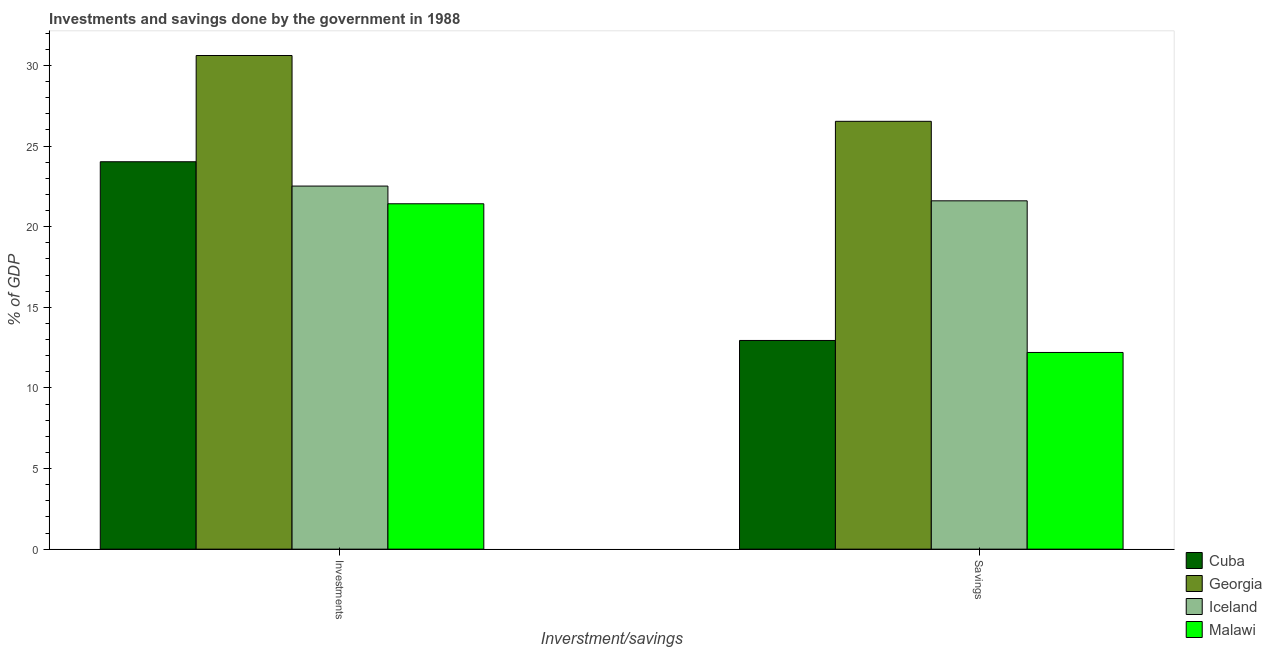How many groups of bars are there?
Ensure brevity in your answer.  2. Are the number of bars on each tick of the X-axis equal?
Keep it short and to the point. Yes. How many bars are there on the 2nd tick from the left?
Make the answer very short. 4. What is the label of the 2nd group of bars from the left?
Offer a very short reply. Savings. What is the savings of government in Georgia?
Ensure brevity in your answer.  26.53. Across all countries, what is the maximum savings of government?
Your response must be concise. 26.53. Across all countries, what is the minimum savings of government?
Your answer should be compact. 12.2. In which country was the savings of government maximum?
Ensure brevity in your answer.  Georgia. In which country was the investments of government minimum?
Provide a succinct answer. Malawi. What is the total savings of government in the graph?
Provide a short and direct response. 73.27. What is the difference between the investments of government in Georgia and that in Cuba?
Make the answer very short. 6.59. What is the difference between the savings of government in Cuba and the investments of government in Iceland?
Make the answer very short. -9.57. What is the average savings of government per country?
Keep it short and to the point. 18.32. What is the difference between the investments of government and savings of government in Malawi?
Ensure brevity in your answer.  9.22. In how many countries, is the savings of government greater than 29 %?
Your response must be concise. 0. What is the ratio of the investments of government in Malawi to that in Georgia?
Give a very brief answer. 0.7. What does the 2nd bar from the left in Savings represents?
Keep it short and to the point. Georgia. What does the 3rd bar from the right in Investments represents?
Your answer should be compact. Georgia. How many bars are there?
Ensure brevity in your answer.  8. Are all the bars in the graph horizontal?
Your response must be concise. No. How many countries are there in the graph?
Provide a short and direct response. 4. Where does the legend appear in the graph?
Ensure brevity in your answer.  Bottom right. How many legend labels are there?
Your answer should be very brief. 4. What is the title of the graph?
Provide a short and direct response. Investments and savings done by the government in 1988. What is the label or title of the X-axis?
Your answer should be compact. Inverstment/savings. What is the label or title of the Y-axis?
Give a very brief answer. % of GDP. What is the % of GDP of Cuba in Investments?
Your answer should be very brief. 24.02. What is the % of GDP of Georgia in Investments?
Provide a short and direct response. 30.61. What is the % of GDP in Iceland in Investments?
Ensure brevity in your answer.  22.52. What is the % of GDP in Malawi in Investments?
Your response must be concise. 21.42. What is the % of GDP of Cuba in Savings?
Offer a very short reply. 12.94. What is the % of GDP in Georgia in Savings?
Provide a short and direct response. 26.53. What is the % of GDP of Iceland in Savings?
Your answer should be compact. 21.6. What is the % of GDP of Malawi in Savings?
Keep it short and to the point. 12.2. Across all Inverstment/savings, what is the maximum % of GDP in Cuba?
Offer a terse response. 24.02. Across all Inverstment/savings, what is the maximum % of GDP in Georgia?
Give a very brief answer. 30.61. Across all Inverstment/savings, what is the maximum % of GDP in Iceland?
Provide a short and direct response. 22.52. Across all Inverstment/savings, what is the maximum % of GDP of Malawi?
Provide a short and direct response. 21.42. Across all Inverstment/savings, what is the minimum % of GDP of Cuba?
Your answer should be very brief. 12.94. Across all Inverstment/savings, what is the minimum % of GDP in Georgia?
Offer a terse response. 26.53. Across all Inverstment/savings, what is the minimum % of GDP in Iceland?
Make the answer very short. 21.6. Across all Inverstment/savings, what is the minimum % of GDP in Malawi?
Your answer should be very brief. 12.2. What is the total % of GDP of Cuba in the graph?
Your response must be concise. 36.97. What is the total % of GDP in Georgia in the graph?
Give a very brief answer. 57.14. What is the total % of GDP of Iceland in the graph?
Your answer should be compact. 44.12. What is the total % of GDP of Malawi in the graph?
Provide a short and direct response. 33.62. What is the difference between the % of GDP of Cuba in Investments and that in Savings?
Make the answer very short. 11.08. What is the difference between the % of GDP of Georgia in Investments and that in Savings?
Make the answer very short. 4.08. What is the difference between the % of GDP of Iceland in Investments and that in Savings?
Your answer should be very brief. 0.91. What is the difference between the % of GDP of Malawi in Investments and that in Savings?
Keep it short and to the point. 9.22. What is the difference between the % of GDP in Cuba in Investments and the % of GDP in Georgia in Savings?
Your response must be concise. -2.51. What is the difference between the % of GDP of Cuba in Investments and the % of GDP of Iceland in Savings?
Your response must be concise. 2.42. What is the difference between the % of GDP of Cuba in Investments and the % of GDP of Malawi in Savings?
Provide a succinct answer. 11.83. What is the difference between the % of GDP in Georgia in Investments and the % of GDP in Iceland in Savings?
Your answer should be compact. 9.01. What is the difference between the % of GDP of Georgia in Investments and the % of GDP of Malawi in Savings?
Keep it short and to the point. 18.41. What is the difference between the % of GDP of Iceland in Investments and the % of GDP of Malawi in Savings?
Keep it short and to the point. 10.32. What is the average % of GDP in Cuba per Inverstment/savings?
Provide a succinct answer. 18.48. What is the average % of GDP of Georgia per Inverstment/savings?
Ensure brevity in your answer.  28.57. What is the average % of GDP in Iceland per Inverstment/savings?
Your response must be concise. 22.06. What is the average % of GDP in Malawi per Inverstment/savings?
Your response must be concise. 16.81. What is the difference between the % of GDP in Cuba and % of GDP in Georgia in Investments?
Keep it short and to the point. -6.59. What is the difference between the % of GDP in Cuba and % of GDP in Iceland in Investments?
Keep it short and to the point. 1.51. What is the difference between the % of GDP in Cuba and % of GDP in Malawi in Investments?
Provide a short and direct response. 2.61. What is the difference between the % of GDP of Georgia and % of GDP of Iceland in Investments?
Give a very brief answer. 8.1. What is the difference between the % of GDP of Georgia and % of GDP of Malawi in Investments?
Keep it short and to the point. 9.19. What is the difference between the % of GDP in Iceland and % of GDP in Malawi in Investments?
Offer a terse response. 1.1. What is the difference between the % of GDP in Cuba and % of GDP in Georgia in Savings?
Offer a very short reply. -13.59. What is the difference between the % of GDP of Cuba and % of GDP of Iceland in Savings?
Keep it short and to the point. -8.66. What is the difference between the % of GDP in Cuba and % of GDP in Malawi in Savings?
Offer a very short reply. 0.74. What is the difference between the % of GDP in Georgia and % of GDP in Iceland in Savings?
Provide a short and direct response. 4.93. What is the difference between the % of GDP in Georgia and % of GDP in Malawi in Savings?
Offer a terse response. 14.33. What is the difference between the % of GDP of Iceland and % of GDP of Malawi in Savings?
Offer a very short reply. 9.4. What is the ratio of the % of GDP of Cuba in Investments to that in Savings?
Your answer should be very brief. 1.86. What is the ratio of the % of GDP of Georgia in Investments to that in Savings?
Your answer should be very brief. 1.15. What is the ratio of the % of GDP of Iceland in Investments to that in Savings?
Your response must be concise. 1.04. What is the ratio of the % of GDP of Malawi in Investments to that in Savings?
Provide a short and direct response. 1.76. What is the difference between the highest and the second highest % of GDP of Cuba?
Your response must be concise. 11.08. What is the difference between the highest and the second highest % of GDP of Georgia?
Ensure brevity in your answer.  4.08. What is the difference between the highest and the second highest % of GDP of Iceland?
Ensure brevity in your answer.  0.91. What is the difference between the highest and the second highest % of GDP of Malawi?
Ensure brevity in your answer.  9.22. What is the difference between the highest and the lowest % of GDP of Cuba?
Ensure brevity in your answer.  11.08. What is the difference between the highest and the lowest % of GDP in Georgia?
Your answer should be very brief. 4.08. What is the difference between the highest and the lowest % of GDP of Iceland?
Give a very brief answer. 0.91. What is the difference between the highest and the lowest % of GDP in Malawi?
Make the answer very short. 9.22. 